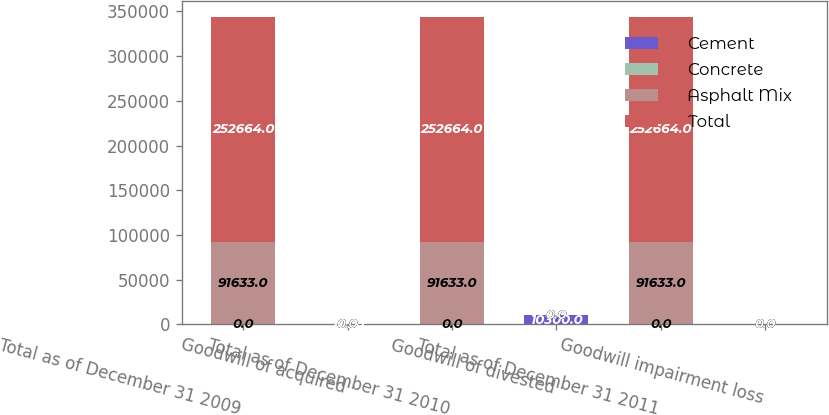<chart> <loc_0><loc_0><loc_500><loc_500><stacked_bar_chart><ecel><fcel>Total as of December 31 2009<fcel>Goodwill of acquired<fcel>Total as of December 31 2010<fcel>Goodwill of divested<fcel>Total as of December 31 2011<fcel>Goodwill impairment loss<nl><fcel>Cement<fcel>0<fcel>716<fcel>0<fcel>10300<fcel>0<fcel>0<nl><fcel>Concrete<fcel>0<fcel>0<fcel>0<fcel>0<fcel>0<fcel>0<nl><fcel>Asphalt Mix<fcel>91633<fcel>0<fcel>91633<fcel>0<fcel>91633<fcel>0<nl><fcel>Total<fcel>252664<fcel>0<fcel>252664<fcel>0<fcel>252664<fcel>0<nl></chart> 